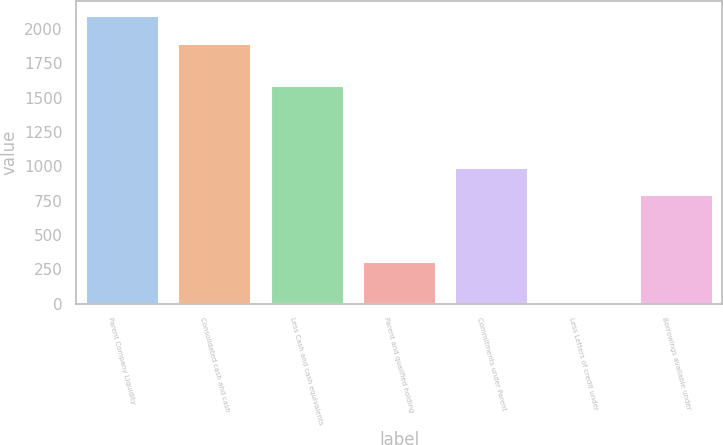Convert chart. <chart><loc_0><loc_0><loc_500><loc_500><bar_chart><fcel>Parent Company Liquidity<fcel>Consolidated cash and cash<fcel>Less Cash and cash equivalents<fcel>Parent and qualified holding<fcel>Commitments under Parent<fcel>Less Letters of credit under<fcel>Borrowings available under<nl><fcel>2100.7<fcel>1900<fcel>1589<fcel>311<fcel>995.7<fcel>5<fcel>795<nl></chart> 